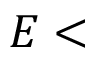<formula> <loc_0><loc_0><loc_500><loc_500>E <</formula> 